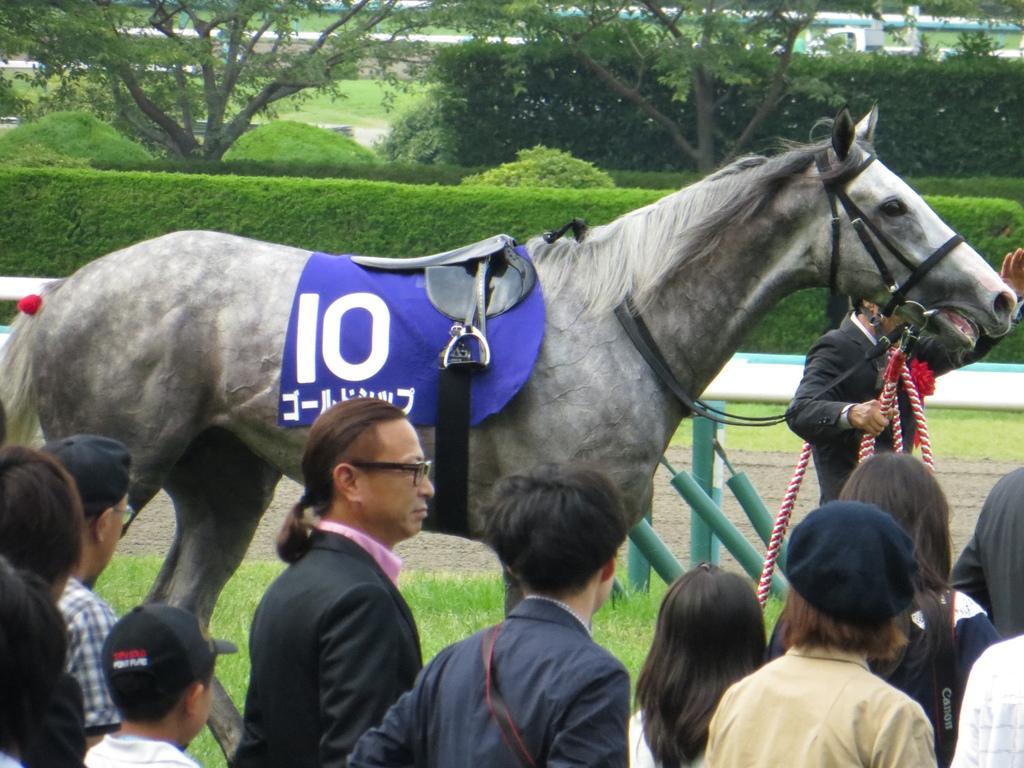Describe this image in one or two sentences. Here we can see a horse and a paddle on it, and here a person is standing, and here a group of persons are standing, and here are the trees, and here is the grass. 